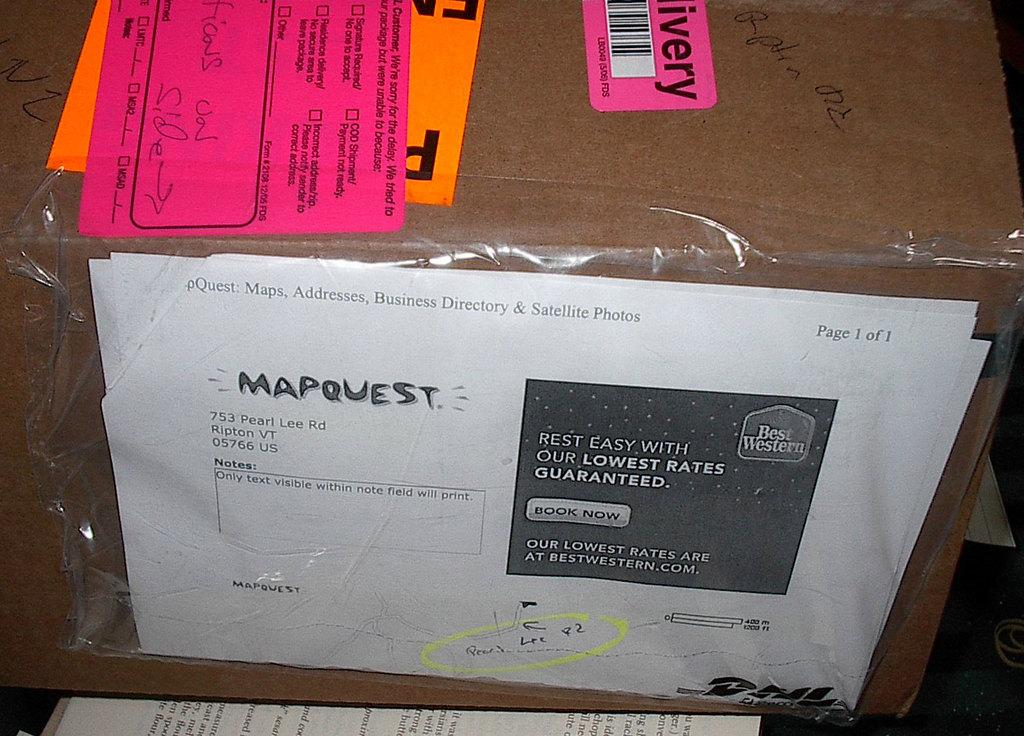<image>
Describe the image concisely. A piece of junk mail with the word mapquest on it. 